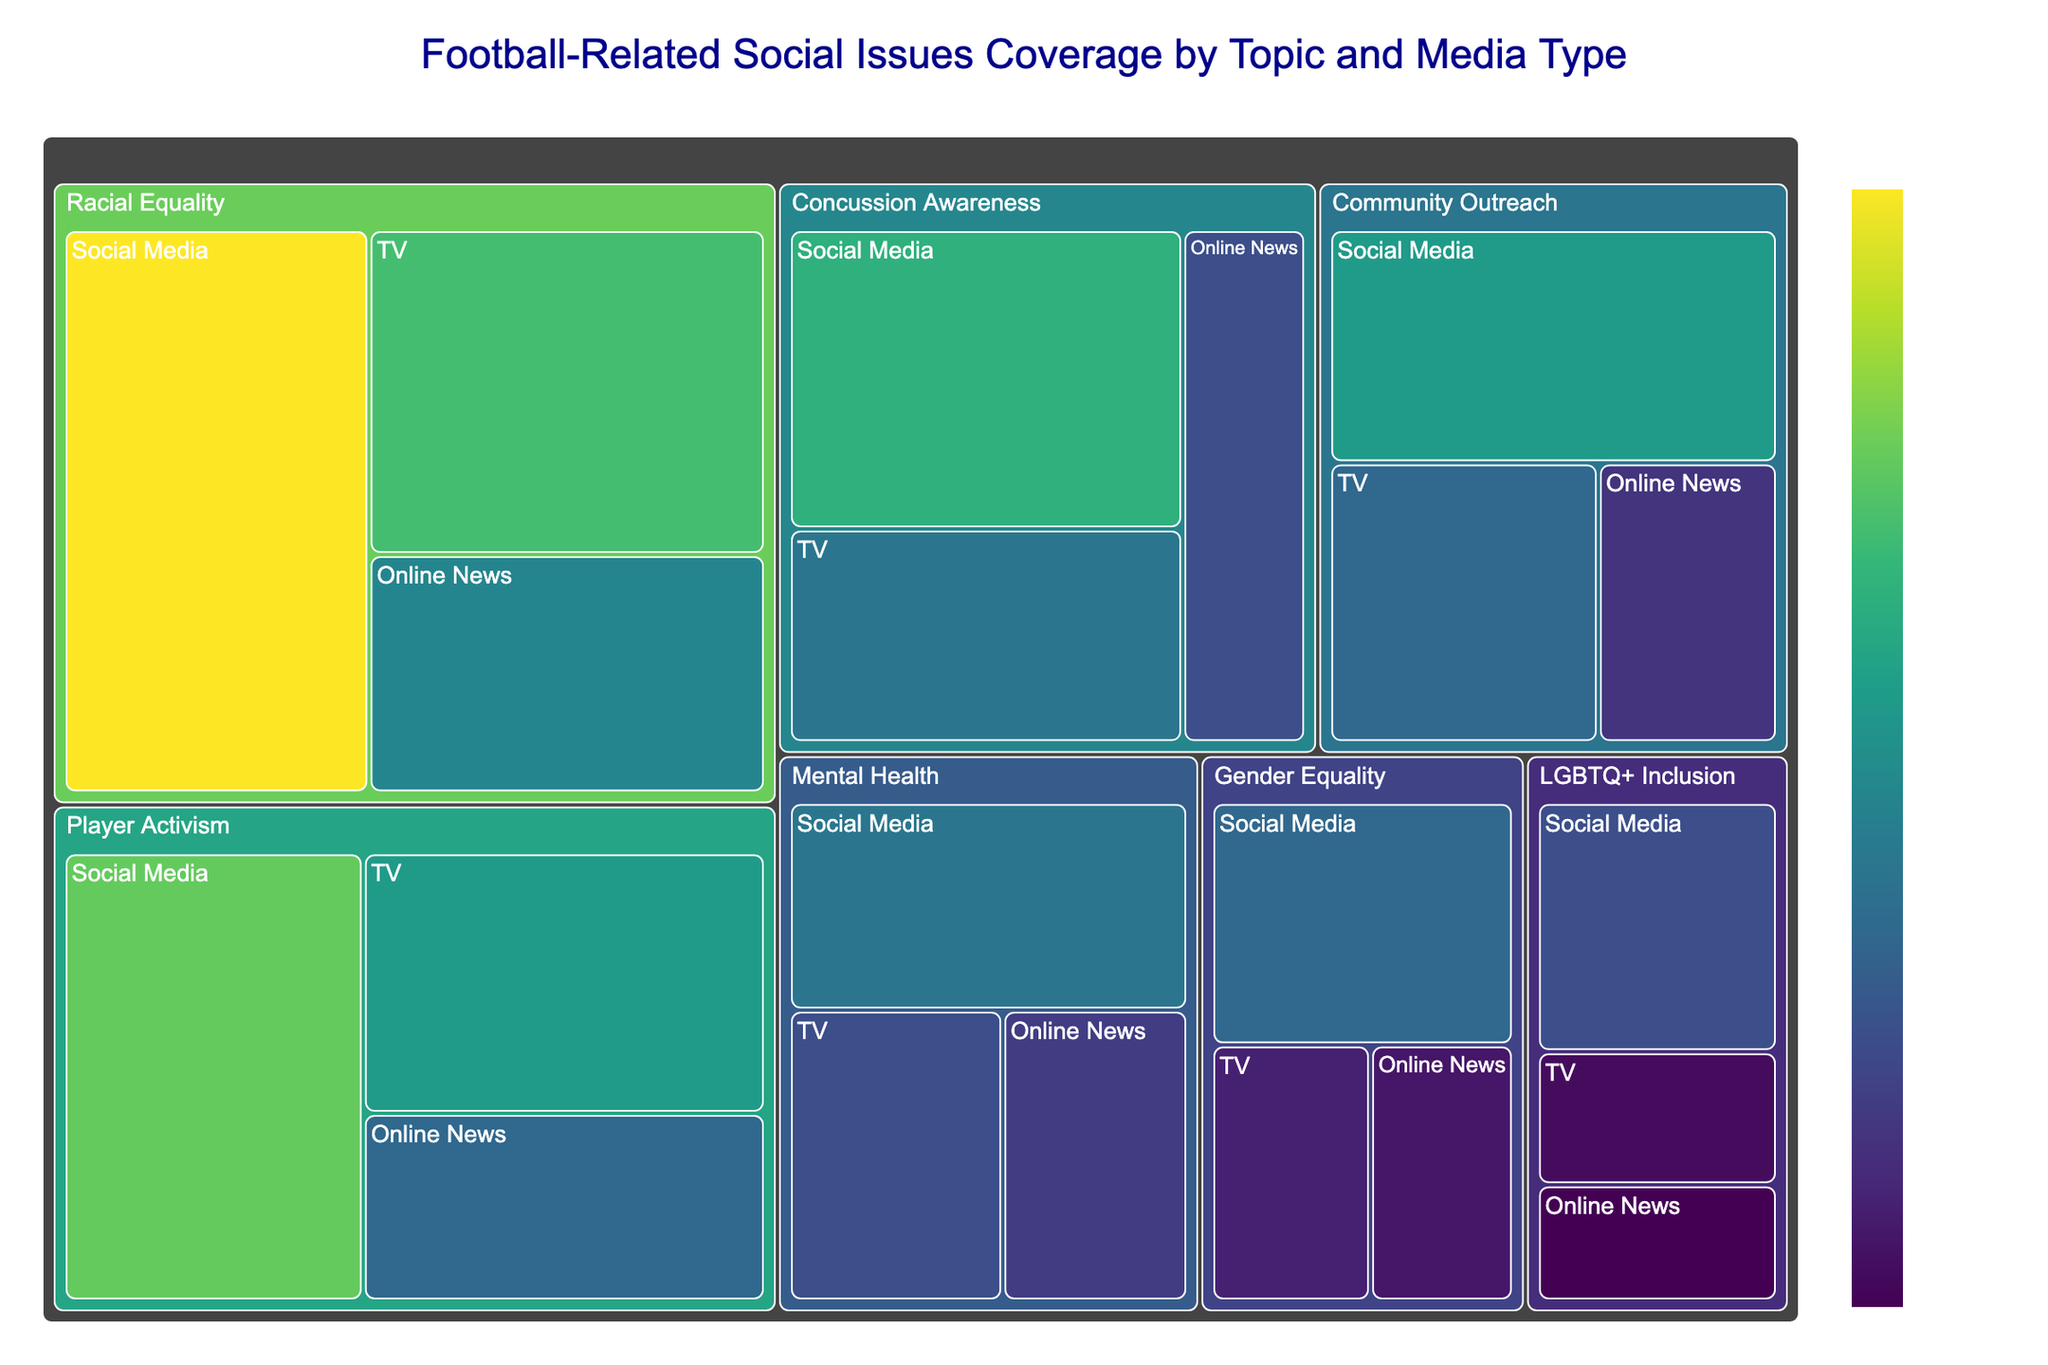What is the title of the treemap? The title is displayed at the top center of the treemap and specifically summarizes what the visualization represents.
Answer: Football-Related Social Issues Coverage by Topic and Media Type Which topic has the highest coverage in social media? Identify all the coverage areas for social media across different topics and compare them to see which is the largest.
Answer: Racial Equality What is the total coverage area for Player Activism across all media types? Add up the coverage areas for Player Activism in TV, Online News, and Social Media: 250 + 180 + 320.
Answer: 750 Compare the coverage of Mental Health on TV and Social Media. Which is higher? Check the coverage areas of Mental Health in TV and Social Media. TV has 150, while Social Media has 200, so Social Media is higher.
Answer: Social Media Which media type has the smallest coverage area for LGBTQ+ Inclusion? Look at the coverage areas for LGBTQ+ Inclusion across TV, Online News, and Social Media and identify the smallest one.
Answer: Online News By how much does the coverage area of Racial Equality on TV exceed that of Concussion Awareness on Online News? Subtract the coverage area of Concussion Awareness on Online News from Racial Equality on TV: 300 - 150.
Answer: 150 How does the average coverage area of Gender Equality compare to that of Community Outreach? Calculate the average coverage area for both Gender Equality and Community Outreach, and then compare them. Gender Equality: (100 + 90 + 180)/3 = 370/3 ≈ 123.33; Community Outreach: (180 + 120 + 250)/3 = 550/3 ≈ 183.33. Thus, Community Outreach has a higher average.
Answer: Community Outreach What is the overall coverage for all TV-related topics combined? Add the TV coverage for all topics: 250 + 300 + 150 + 100 + 180 + 200 + 80.
Answer: 1260 